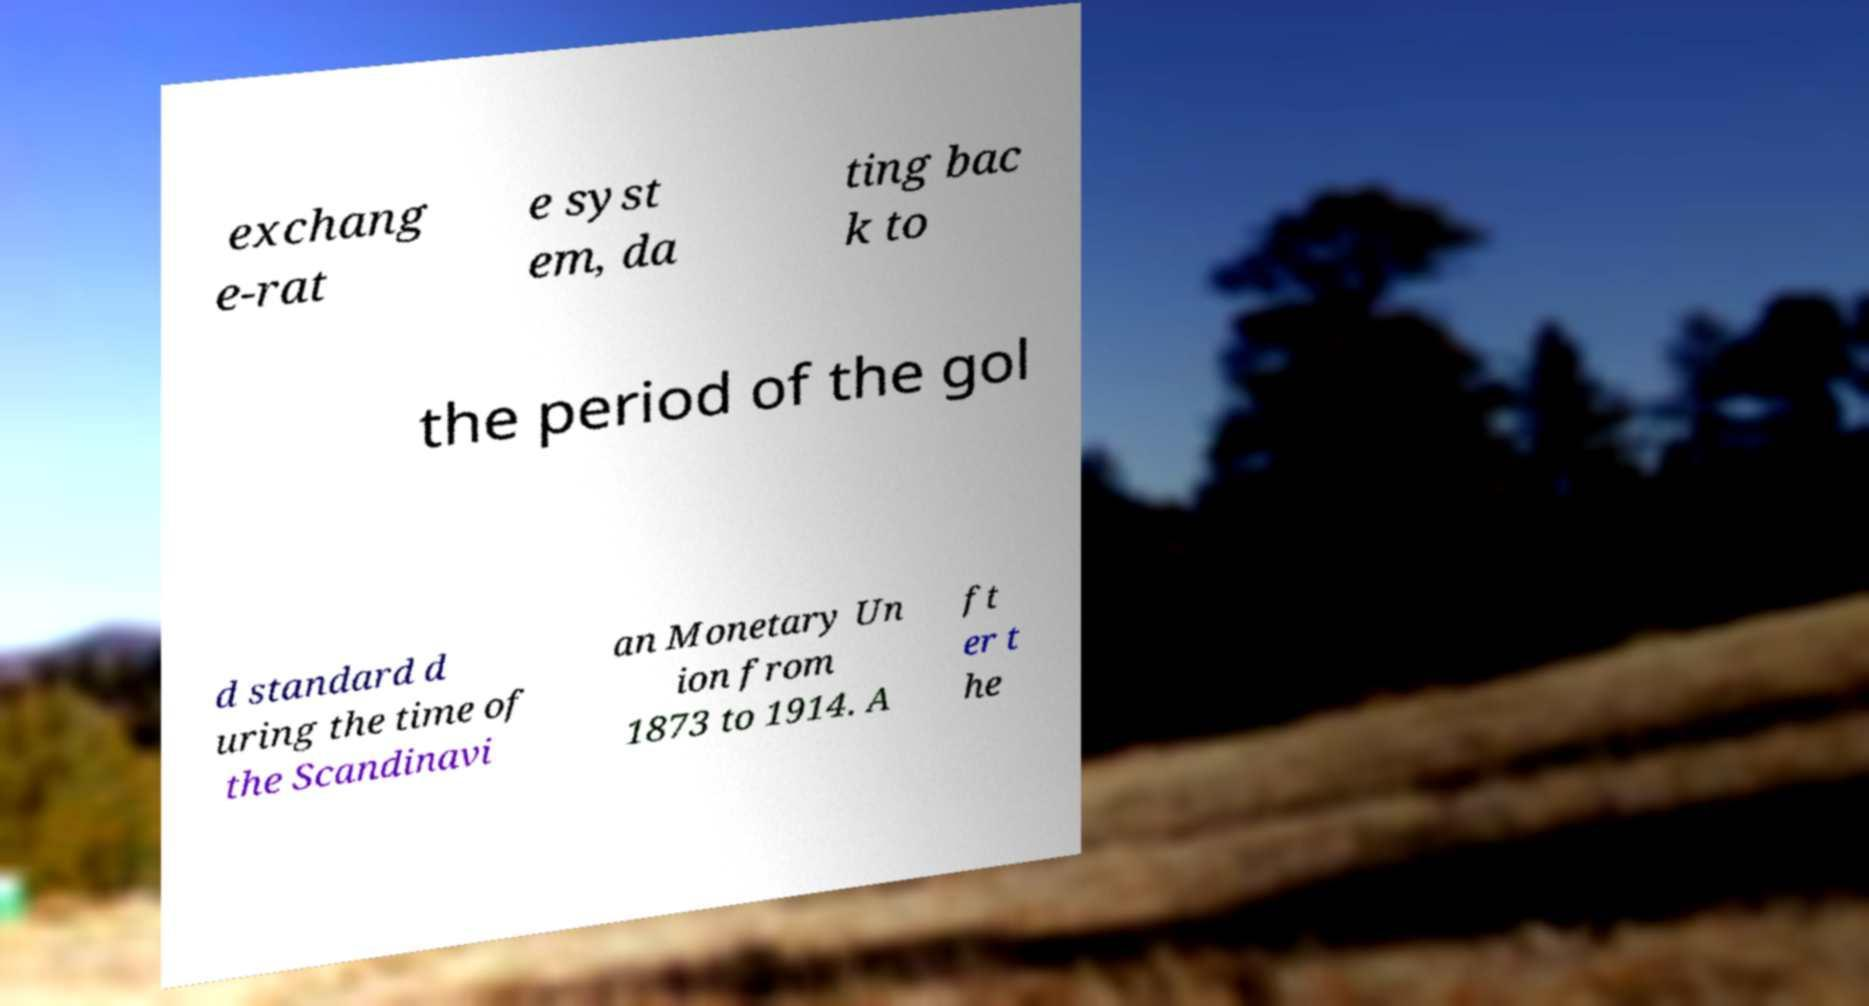For documentation purposes, I need the text within this image transcribed. Could you provide that? exchang e-rat e syst em, da ting bac k to the period of the gol d standard d uring the time of the Scandinavi an Monetary Un ion from 1873 to 1914. A ft er t he 